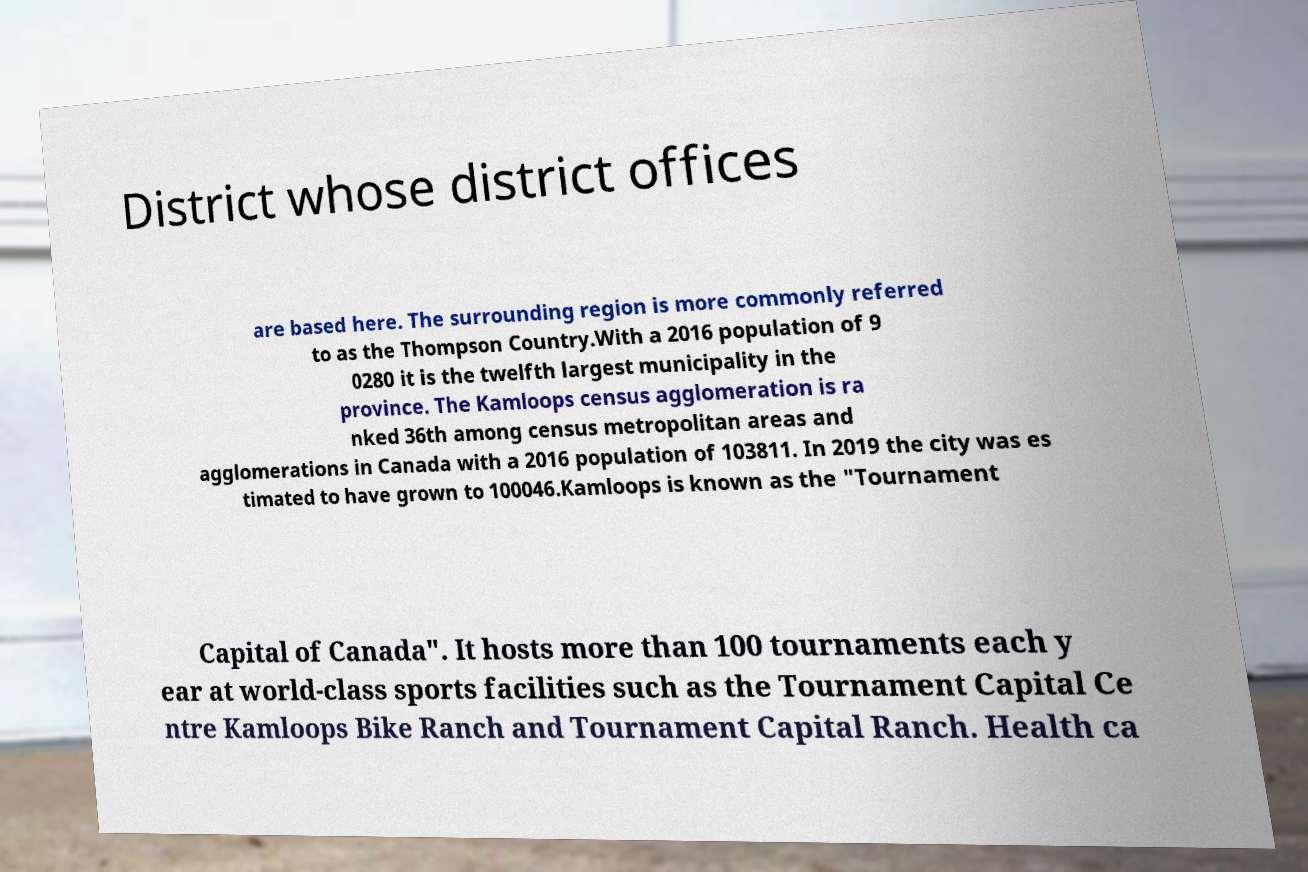Please identify and transcribe the text found in this image. District whose district offices are based here. The surrounding region is more commonly referred to as the Thompson Country.With a 2016 population of 9 0280 it is the twelfth largest municipality in the province. The Kamloops census agglomeration is ra nked 36th among census metropolitan areas and agglomerations in Canada with a 2016 population of 103811. In 2019 the city was es timated to have grown to 100046.Kamloops is known as the "Tournament Capital of Canada". It hosts more than 100 tournaments each y ear at world-class sports facilities such as the Tournament Capital Ce ntre Kamloops Bike Ranch and Tournament Capital Ranch. Health ca 